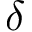Convert formula to latex. <formula><loc_0><loc_0><loc_500><loc_500>\delta</formula> 